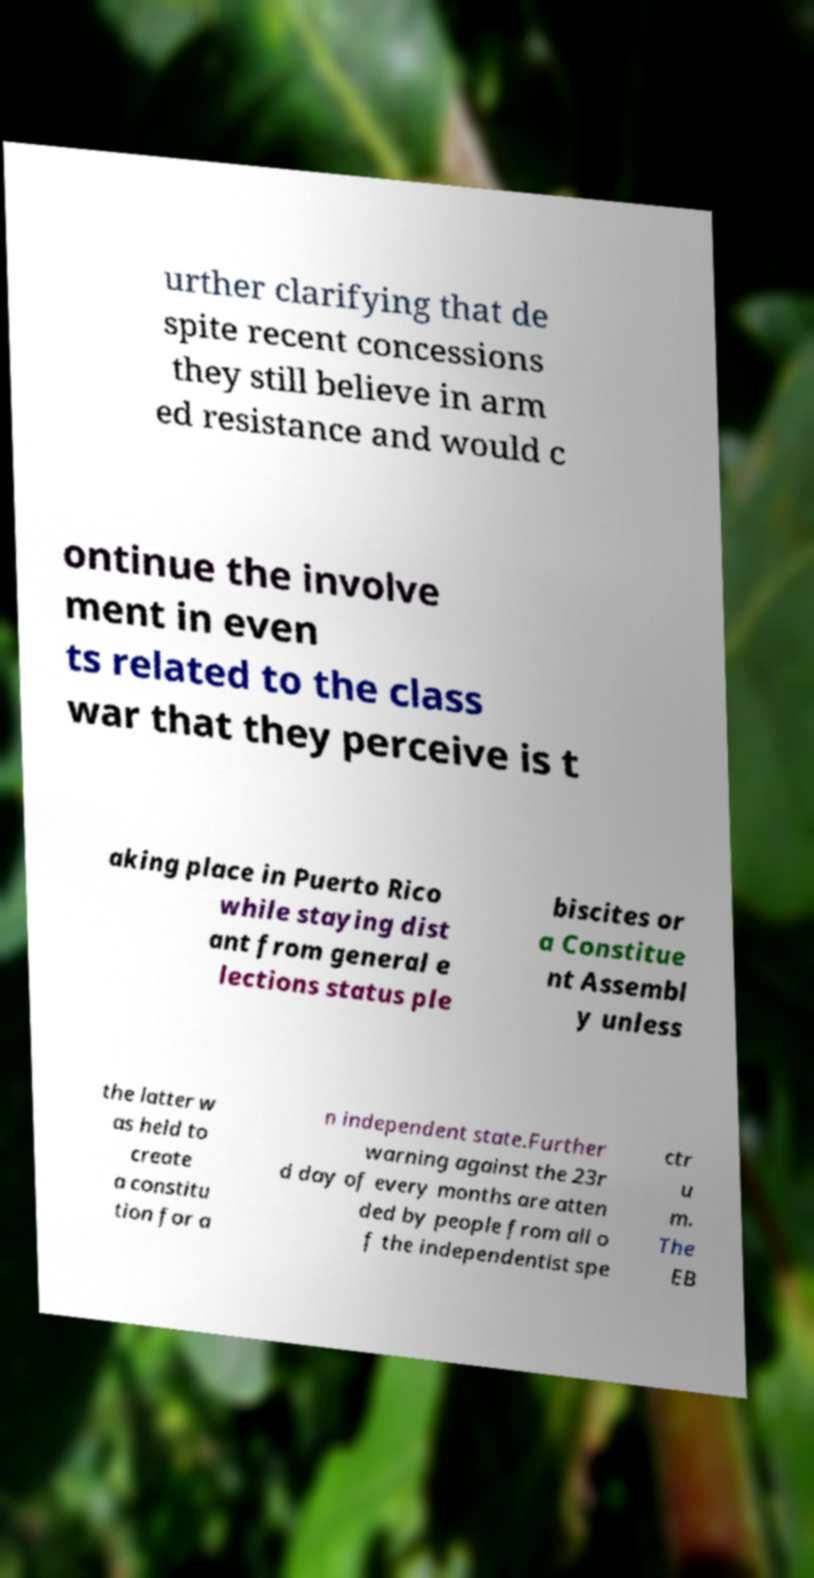I need the written content from this picture converted into text. Can you do that? urther clarifying that de spite recent concessions they still believe in arm ed resistance and would c ontinue the involve ment in even ts related to the class war that they perceive is t aking place in Puerto Rico while staying dist ant from general e lections status ple biscites or a Constitue nt Assembl y unless the latter w as held to create a constitu tion for a n independent state.Further warning against the 23r d day of every months are atten ded by people from all o f the independentist spe ctr u m. The EB 